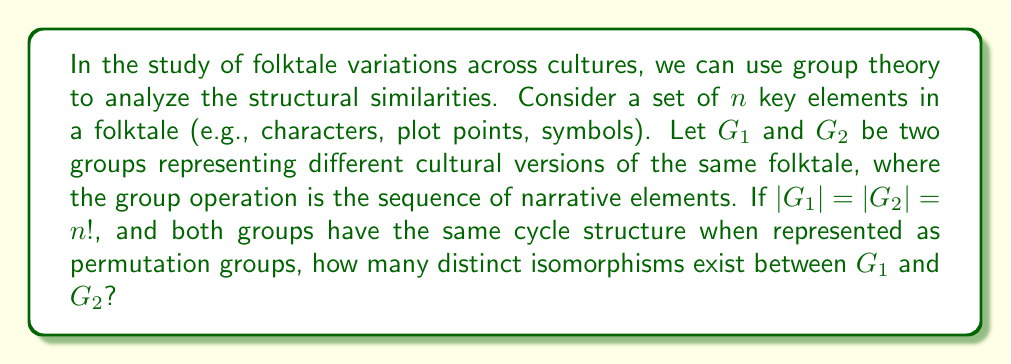What is the answer to this math problem? To solve this problem, we need to follow these steps:

1) First, we recognize that both $G_1$ and $G_2$ are isomorphic to the symmetric group $S_n$, as they have order $n!$ and represent all possible permutations of $n$ elements.

2) The number of isomorphisms between two groups is equal to the number of ways to map the generators of one group to the generators of the other group, while preserving the group structure.

3) In $S_n$, we can generate the entire group using transpositions (2-cycles). Specifically, we need $n-1$ transpositions to generate $S_n$.

4) The number of ways to choose these $n-1$ transpositions in $G_2$ that correspond to the $n-1$ generating transpositions in $G_1$ is:

   $$(n(n-1)/2) \cdot ((n-1)(n-2)/2) \cdot ... \cdot (3 \cdot 2/2) \cdot (2 \cdot 1/2)$$

5) This product simplifies to:

   $$\frac{n!}{2^{n-1}}$$

6) However, this counts each isomorphism multiple times, as there are $(n-1)!$ ways to order the $n-1$ transpositions.

7) Therefore, we need to divide by $(n-1)!$ to get the correct count of distinct isomorphisms.

Thus, the final number of distinct isomorphisms is:

$$\frac{n!}{2^{n-1}(n-1)!} = \frac{n}{2^{n-1}}$$

This formula gives us the number of ways to map the structure of one cultural version of the folktale to another, preserving the relationships between narrative elements.
Answer: The number of distinct isomorphisms between $G_1$ and $G_2$ is $\frac{n}{2^{n-1}}$, where $n$ is the number of key elements in the folktale. 